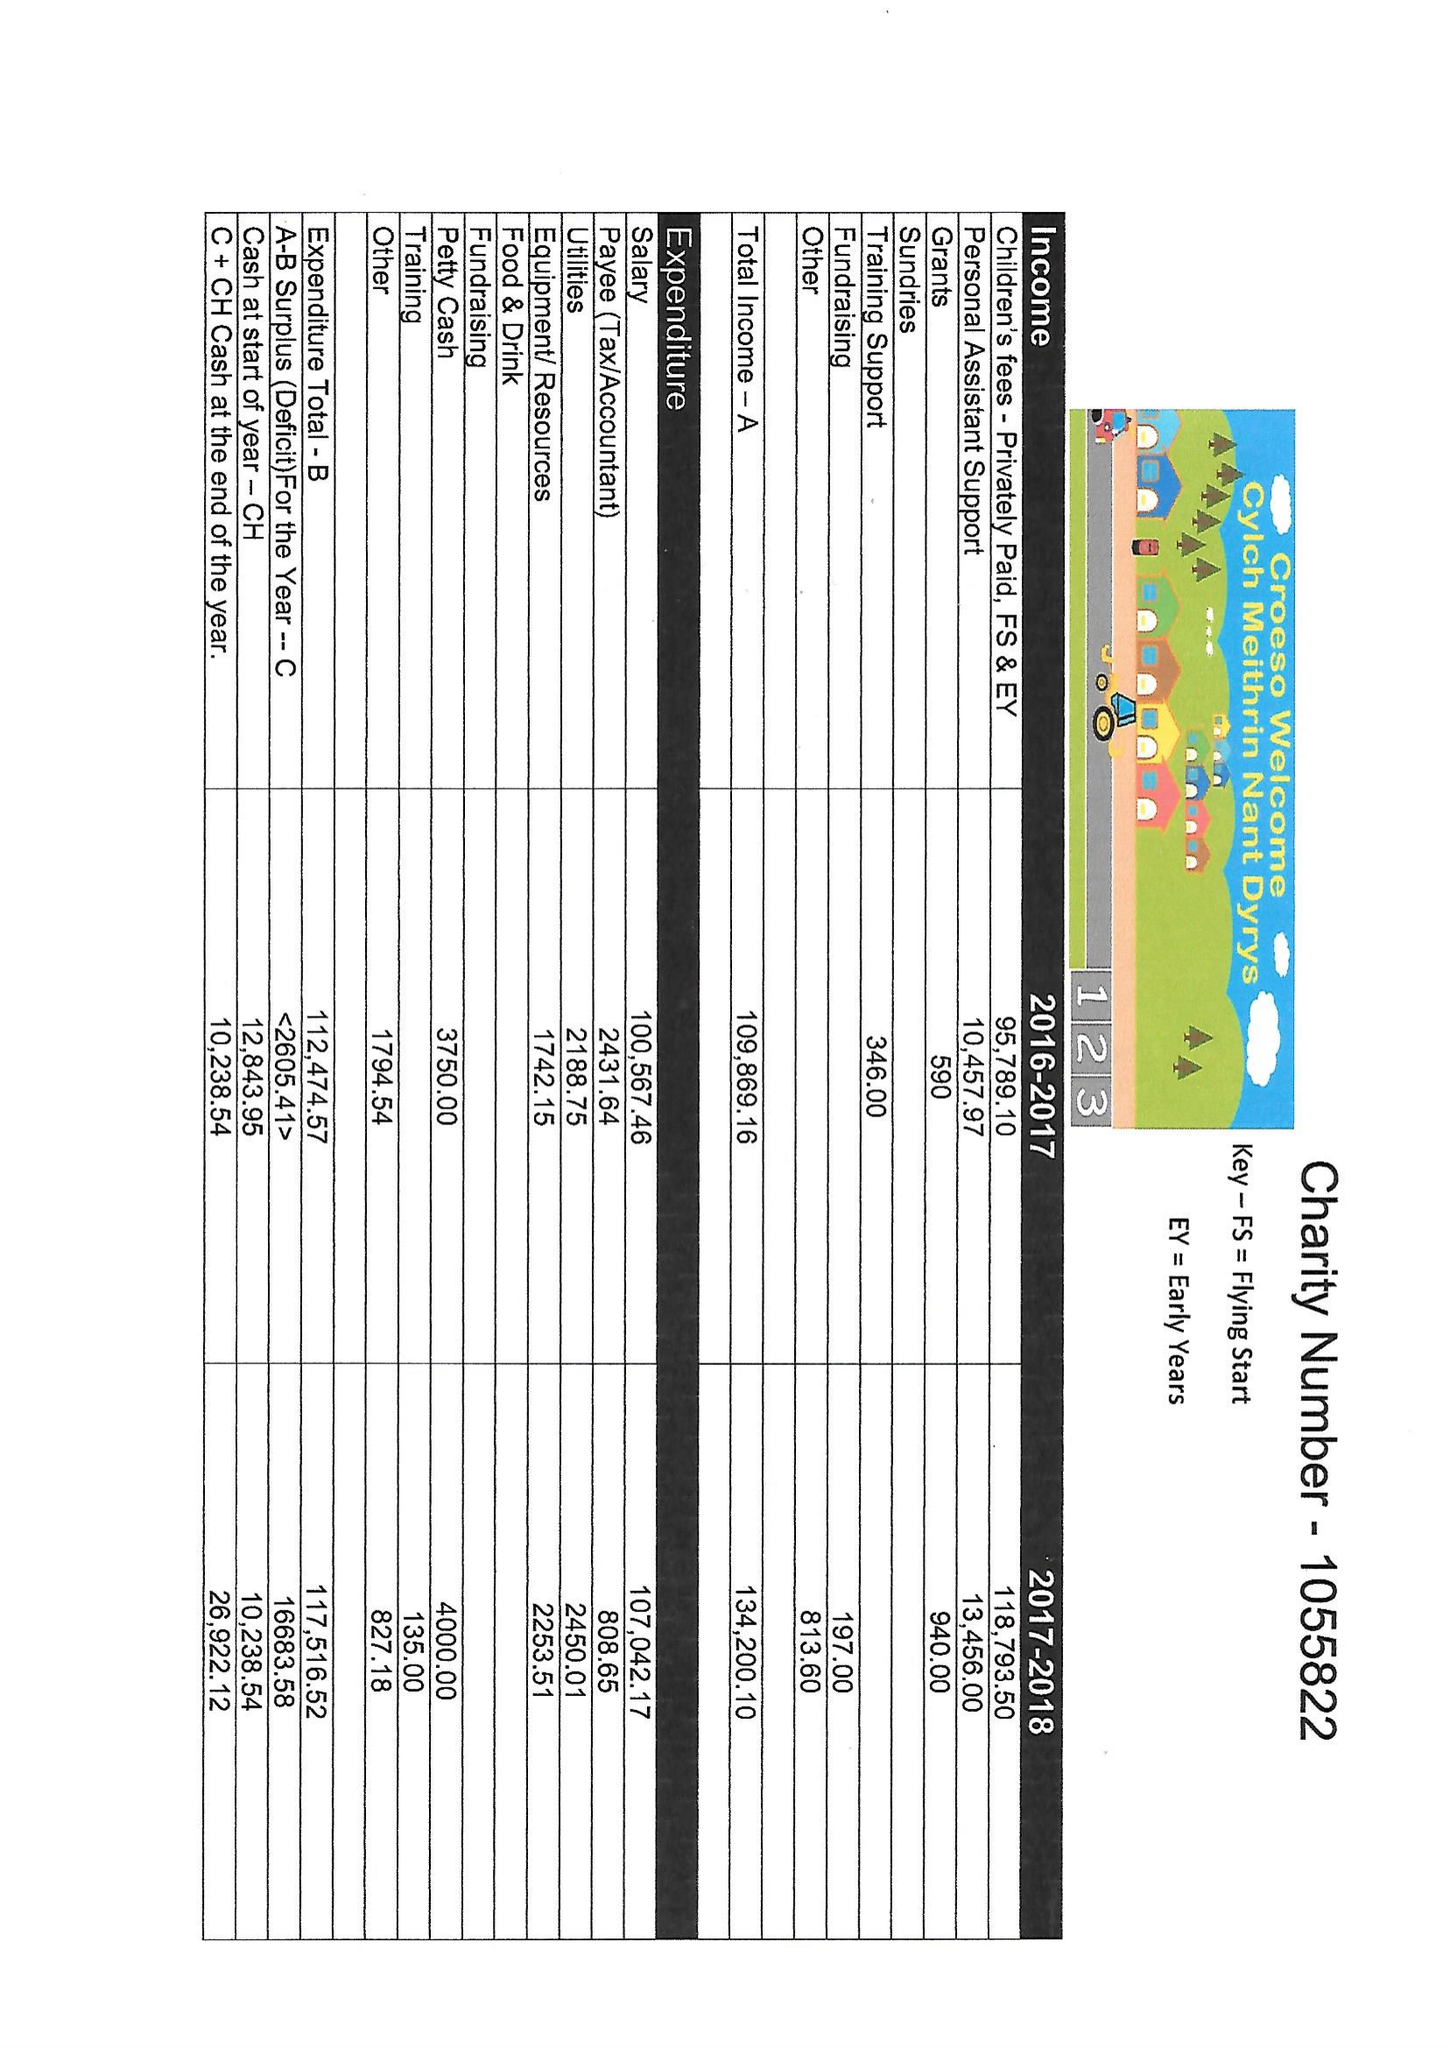What is the value for the address__post_town?
Answer the question using a single word or phrase. TREORCHY 